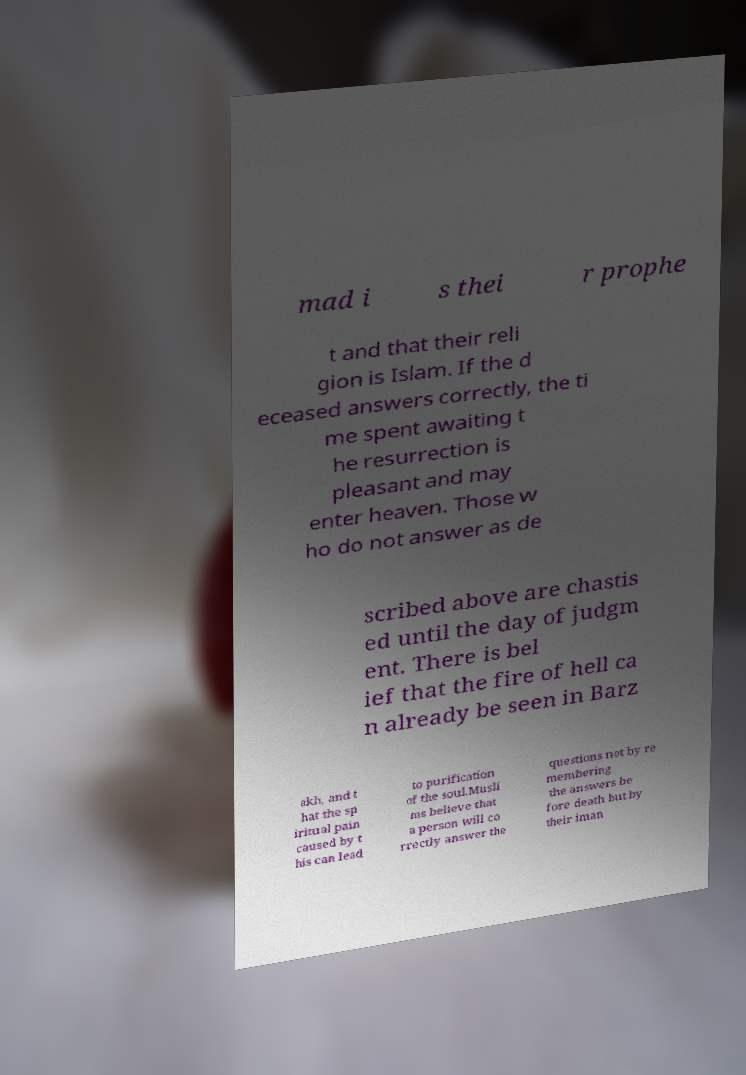Could you assist in decoding the text presented in this image and type it out clearly? mad i s thei r prophe t and that their reli gion is Islam. If the d eceased answers correctly, the ti me spent awaiting t he resurrection is pleasant and may enter heaven. Those w ho do not answer as de scribed above are chastis ed until the day of judgm ent. There is bel ief that the fire of hell ca n already be seen in Barz akh, and t hat the sp iritual pain caused by t his can lead to purification of the soul.Musli ms believe that a person will co rrectly answer the questions not by re membering the answers be fore death but by their iman 